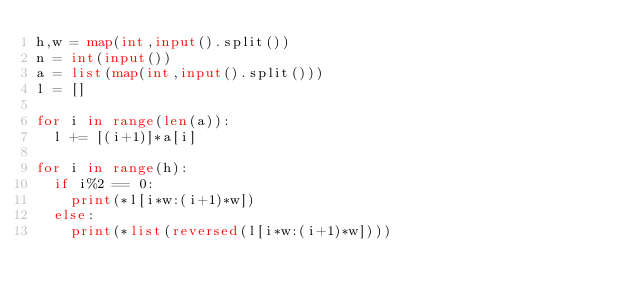Convert code to text. <code><loc_0><loc_0><loc_500><loc_500><_Python_>h,w = map(int,input().split())
n = int(input())
a = list(map(int,input().split()))
l = []

for i in range(len(a)):
  l += [(i+1)]*a[i]
  
for i in range(h):
  if i%2 == 0:
    print(*l[i*w:(i+1)*w])
  else:
    print(*list(reversed(l[i*w:(i+1)*w])))</code> 